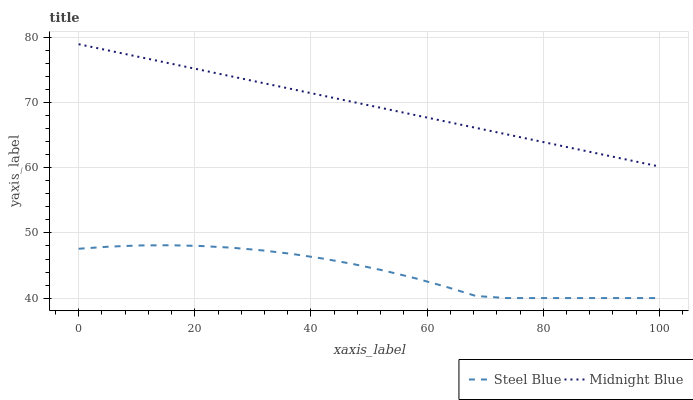Does Steel Blue have the minimum area under the curve?
Answer yes or no. Yes. Does Midnight Blue have the maximum area under the curve?
Answer yes or no. Yes. Does Midnight Blue have the minimum area under the curve?
Answer yes or no. No. Is Midnight Blue the smoothest?
Answer yes or no. Yes. Is Steel Blue the roughest?
Answer yes or no. Yes. Is Midnight Blue the roughest?
Answer yes or no. No. Does Steel Blue have the lowest value?
Answer yes or no. Yes. Does Midnight Blue have the lowest value?
Answer yes or no. No. Does Midnight Blue have the highest value?
Answer yes or no. Yes. Is Steel Blue less than Midnight Blue?
Answer yes or no. Yes. Is Midnight Blue greater than Steel Blue?
Answer yes or no. Yes. Does Steel Blue intersect Midnight Blue?
Answer yes or no. No. 